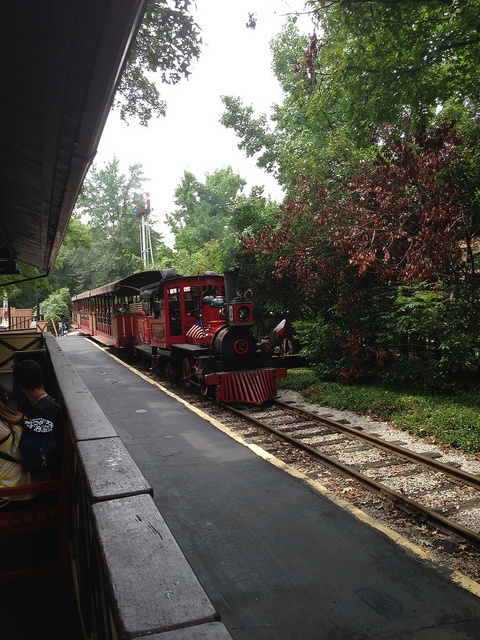Describe the objects in this image and their specific colors. I can see train in black, maroon, gray, and brown tones, people in black, gray, maroon, and darkgray tones, people in black, olive, and gray tones, traffic light in black, gray, darkgray, and tan tones, and people in black, gray, and lightgray tones in this image. 